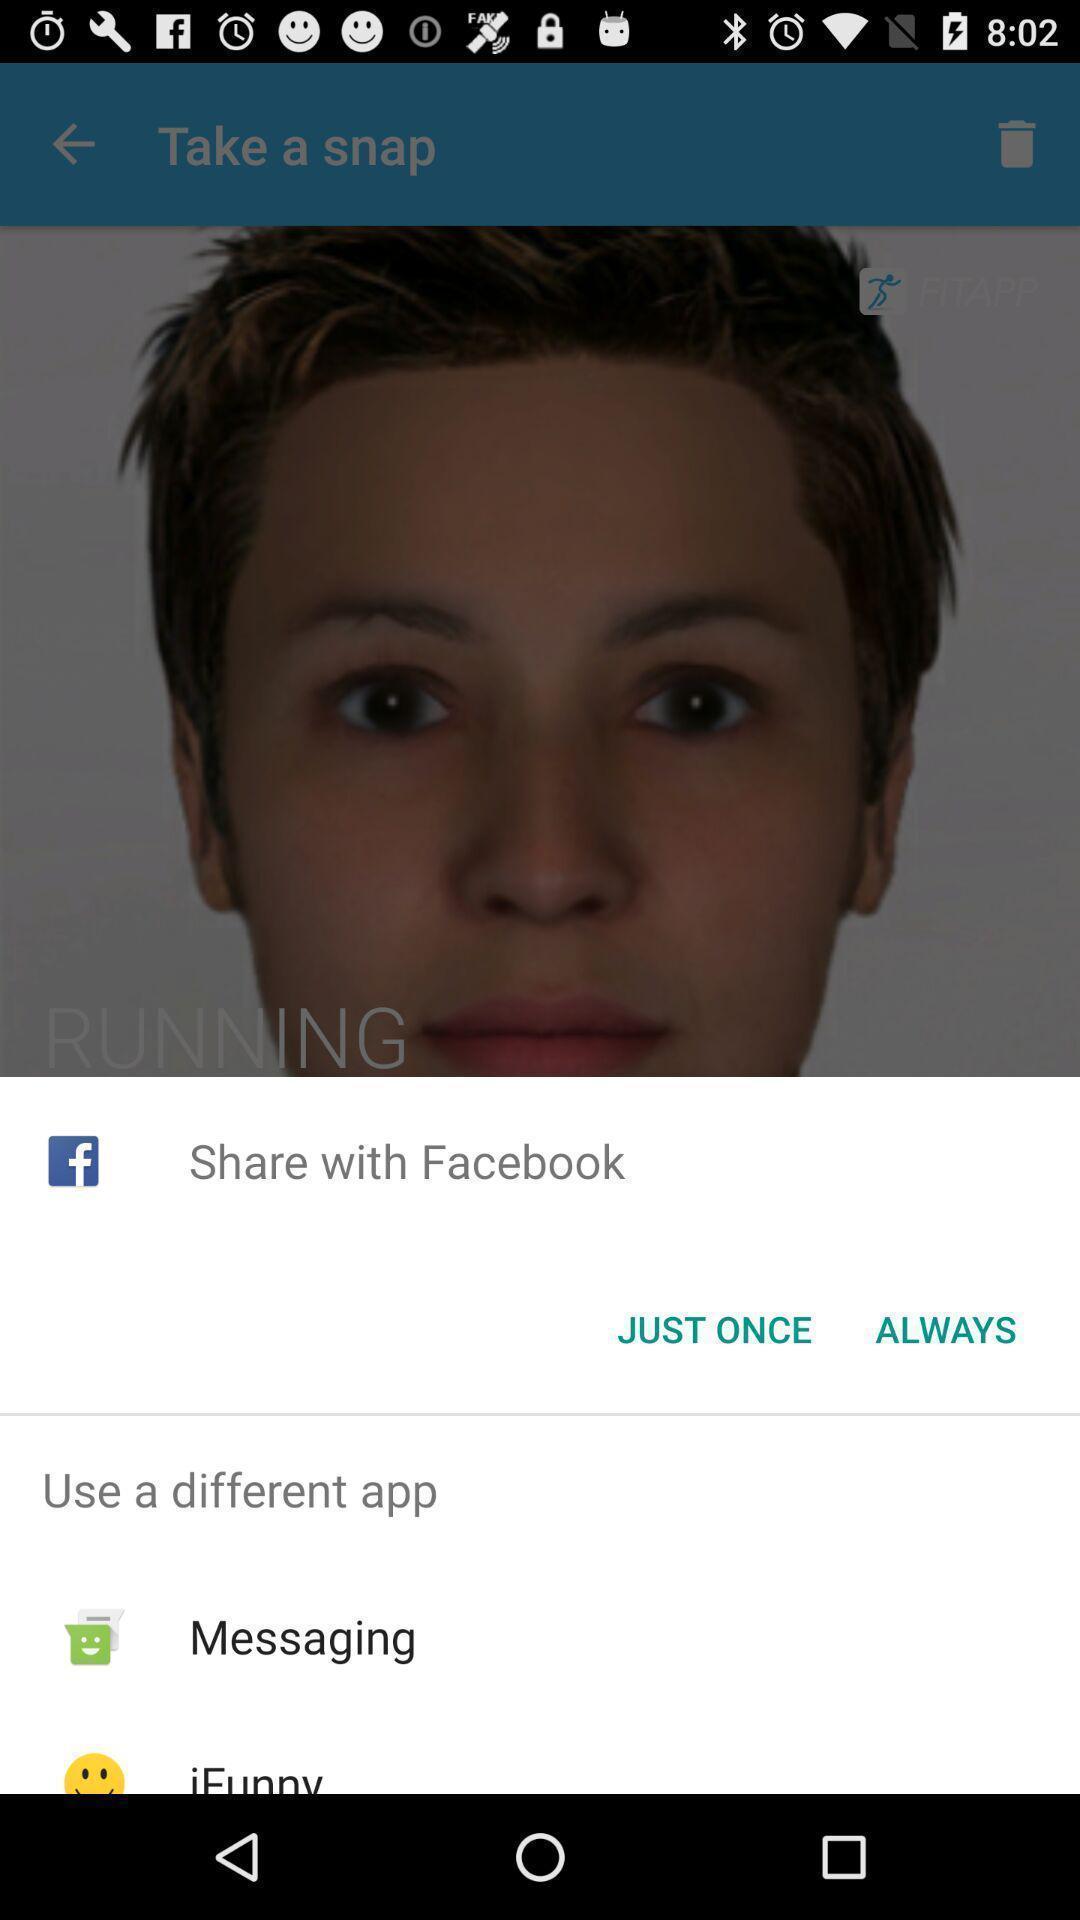What details can you identify in this image? Popup of applications to share the image. 